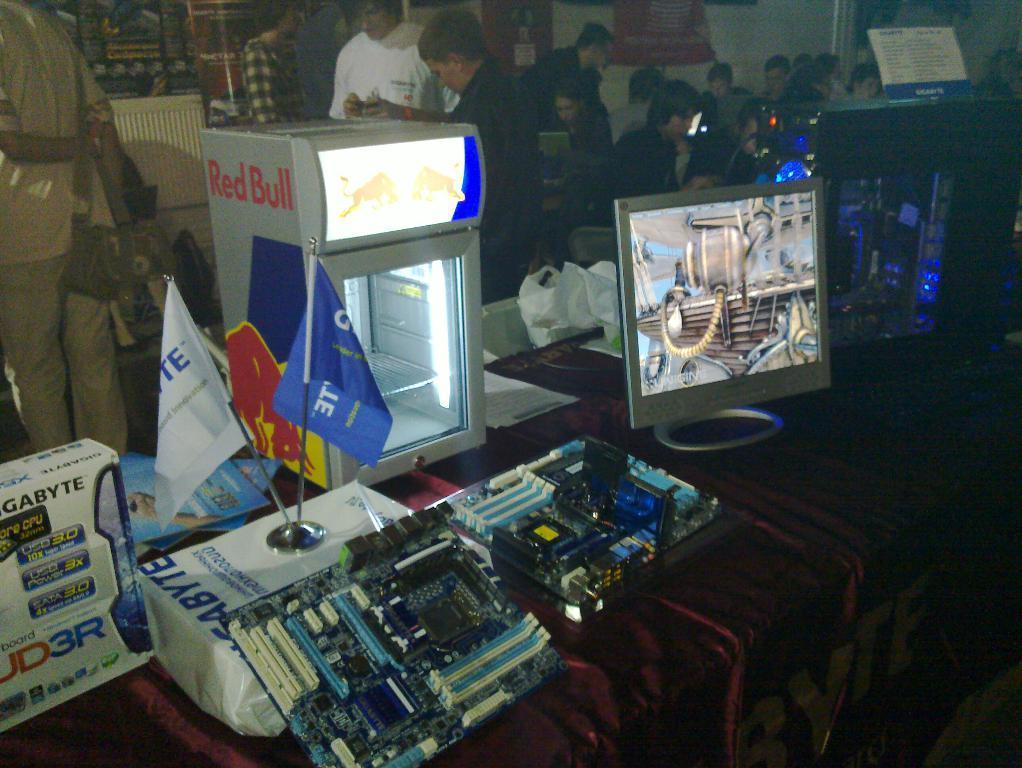In one or two sentences, can you explain what this image depicts? In the center of the image there is a table. On the table we can see screen refrigerator, flags, box and some objects are there. At the top of the image a group of people are there. At the bottom right corner floor is present. 